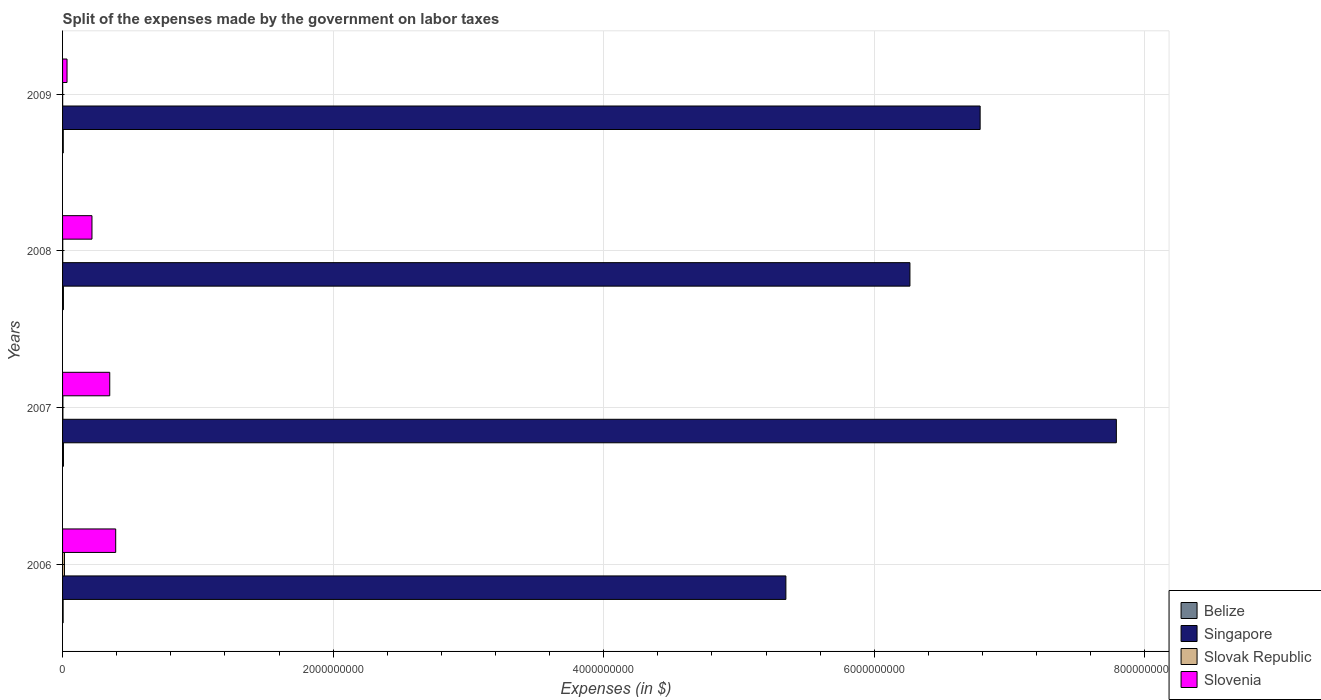How many different coloured bars are there?
Keep it short and to the point. 4. How many groups of bars are there?
Offer a terse response. 4. How many bars are there on the 4th tick from the top?
Ensure brevity in your answer.  4. How many bars are there on the 4th tick from the bottom?
Your response must be concise. 4. What is the label of the 2nd group of bars from the top?
Ensure brevity in your answer.  2008. What is the expenses made by the government on labor taxes in Belize in 2008?
Your answer should be very brief. 6.32e+06. Across all years, what is the maximum expenses made by the government on labor taxes in Slovak Republic?
Your response must be concise. 1.41e+07. Across all years, what is the minimum expenses made by the government on labor taxes in Belize?
Keep it short and to the point. 4.30e+06. In which year was the expenses made by the government on labor taxes in Slovenia maximum?
Make the answer very short. 2006. In which year was the expenses made by the government on labor taxes in Slovak Republic minimum?
Your answer should be compact. 2009. What is the total expenses made by the government on labor taxes in Singapore in the graph?
Ensure brevity in your answer.  2.62e+1. What is the difference between the expenses made by the government on labor taxes in Slovak Republic in 2006 and that in 2008?
Make the answer very short. 1.27e+07. What is the difference between the expenses made by the government on labor taxes in Singapore in 2006 and the expenses made by the government on labor taxes in Slovenia in 2007?
Give a very brief answer. 5.00e+09. What is the average expenses made by the government on labor taxes in Singapore per year?
Offer a very short reply. 6.55e+09. In the year 2006, what is the difference between the expenses made by the government on labor taxes in Slovenia and expenses made by the government on labor taxes in Singapore?
Your answer should be very brief. -4.95e+09. What is the ratio of the expenses made by the government on labor taxes in Singapore in 2007 to that in 2008?
Your answer should be compact. 1.24. What is the difference between the highest and the second highest expenses made by the government on labor taxes in Belize?
Give a very brief answer. 1.98e+05. What is the difference between the highest and the lowest expenses made by the government on labor taxes in Belize?
Ensure brevity in your answer.  2.22e+06. In how many years, is the expenses made by the government on labor taxes in Singapore greater than the average expenses made by the government on labor taxes in Singapore taken over all years?
Keep it short and to the point. 2. What does the 2nd bar from the top in 2009 represents?
Offer a terse response. Slovak Republic. What does the 3rd bar from the bottom in 2006 represents?
Your answer should be very brief. Slovak Republic. Is it the case that in every year, the sum of the expenses made by the government on labor taxes in Belize and expenses made by the government on labor taxes in Slovenia is greater than the expenses made by the government on labor taxes in Slovak Republic?
Provide a short and direct response. Yes. Are the values on the major ticks of X-axis written in scientific E-notation?
Offer a terse response. No. Does the graph contain any zero values?
Ensure brevity in your answer.  No. Where does the legend appear in the graph?
Keep it short and to the point. Bottom right. How are the legend labels stacked?
Offer a terse response. Vertical. What is the title of the graph?
Your answer should be compact. Split of the expenses made by the government on labor taxes. What is the label or title of the X-axis?
Your response must be concise. Expenses (in $). What is the Expenses (in $) in Belize in 2006?
Give a very brief answer. 4.30e+06. What is the Expenses (in $) of Singapore in 2006?
Offer a terse response. 5.35e+09. What is the Expenses (in $) in Slovak Republic in 2006?
Provide a short and direct response. 1.41e+07. What is the Expenses (in $) in Slovenia in 2006?
Give a very brief answer. 3.93e+08. What is the Expenses (in $) in Belize in 2007?
Provide a succinct answer. 6.52e+06. What is the Expenses (in $) in Singapore in 2007?
Ensure brevity in your answer.  7.79e+09. What is the Expenses (in $) of Slovak Republic in 2007?
Provide a short and direct response. 2.58e+06. What is the Expenses (in $) of Slovenia in 2007?
Offer a very short reply. 3.49e+08. What is the Expenses (in $) of Belize in 2008?
Provide a short and direct response. 6.32e+06. What is the Expenses (in $) of Singapore in 2008?
Your answer should be very brief. 6.26e+09. What is the Expenses (in $) of Slovak Republic in 2008?
Provide a succinct answer. 1.39e+06. What is the Expenses (in $) of Slovenia in 2008?
Offer a terse response. 2.17e+08. What is the Expenses (in $) of Belize in 2009?
Give a very brief answer. 5.26e+06. What is the Expenses (in $) of Singapore in 2009?
Offer a terse response. 6.78e+09. What is the Expenses (in $) of Slovak Republic in 2009?
Offer a terse response. 7.25e+05. What is the Expenses (in $) of Slovenia in 2009?
Provide a succinct answer. 3.31e+07. Across all years, what is the maximum Expenses (in $) in Belize?
Your answer should be compact. 6.52e+06. Across all years, what is the maximum Expenses (in $) in Singapore?
Ensure brevity in your answer.  7.79e+09. Across all years, what is the maximum Expenses (in $) in Slovak Republic?
Ensure brevity in your answer.  1.41e+07. Across all years, what is the maximum Expenses (in $) of Slovenia?
Make the answer very short. 3.93e+08. Across all years, what is the minimum Expenses (in $) in Belize?
Offer a very short reply. 4.30e+06. Across all years, what is the minimum Expenses (in $) of Singapore?
Your response must be concise. 5.35e+09. Across all years, what is the minimum Expenses (in $) in Slovak Republic?
Your answer should be very brief. 7.25e+05. Across all years, what is the minimum Expenses (in $) of Slovenia?
Give a very brief answer. 3.31e+07. What is the total Expenses (in $) in Belize in the graph?
Provide a succinct answer. 2.24e+07. What is the total Expenses (in $) in Singapore in the graph?
Offer a very short reply. 2.62e+1. What is the total Expenses (in $) in Slovak Republic in the graph?
Your response must be concise. 1.88e+07. What is the total Expenses (in $) in Slovenia in the graph?
Offer a terse response. 9.92e+08. What is the difference between the Expenses (in $) in Belize in 2006 and that in 2007?
Provide a succinct answer. -2.22e+06. What is the difference between the Expenses (in $) in Singapore in 2006 and that in 2007?
Offer a very short reply. -2.44e+09. What is the difference between the Expenses (in $) in Slovak Republic in 2006 and that in 2007?
Make the answer very short. 1.15e+07. What is the difference between the Expenses (in $) of Slovenia in 2006 and that in 2007?
Give a very brief answer. 4.41e+07. What is the difference between the Expenses (in $) of Belize in 2006 and that in 2008?
Your answer should be very brief. -2.03e+06. What is the difference between the Expenses (in $) of Singapore in 2006 and that in 2008?
Offer a terse response. -9.17e+08. What is the difference between the Expenses (in $) of Slovak Republic in 2006 and that in 2008?
Provide a succinct answer. 1.27e+07. What is the difference between the Expenses (in $) of Slovenia in 2006 and that in 2008?
Provide a short and direct response. 1.75e+08. What is the difference between the Expenses (in $) in Belize in 2006 and that in 2009?
Keep it short and to the point. -9.65e+05. What is the difference between the Expenses (in $) in Singapore in 2006 and that in 2009?
Your answer should be compact. -1.44e+09. What is the difference between the Expenses (in $) in Slovak Republic in 2006 and that in 2009?
Provide a short and direct response. 1.34e+07. What is the difference between the Expenses (in $) of Slovenia in 2006 and that in 2009?
Offer a terse response. 3.60e+08. What is the difference between the Expenses (in $) of Belize in 2007 and that in 2008?
Ensure brevity in your answer.  1.98e+05. What is the difference between the Expenses (in $) in Singapore in 2007 and that in 2008?
Keep it short and to the point. 1.53e+09. What is the difference between the Expenses (in $) of Slovak Republic in 2007 and that in 2008?
Provide a short and direct response. 1.19e+06. What is the difference between the Expenses (in $) in Slovenia in 2007 and that in 2008?
Offer a terse response. 1.31e+08. What is the difference between the Expenses (in $) of Belize in 2007 and that in 2009?
Your answer should be very brief. 1.26e+06. What is the difference between the Expenses (in $) in Singapore in 2007 and that in 2009?
Ensure brevity in your answer.  1.01e+09. What is the difference between the Expenses (in $) in Slovak Republic in 2007 and that in 2009?
Your answer should be compact. 1.86e+06. What is the difference between the Expenses (in $) of Slovenia in 2007 and that in 2009?
Give a very brief answer. 3.16e+08. What is the difference between the Expenses (in $) of Belize in 2008 and that in 2009?
Your response must be concise. 1.06e+06. What is the difference between the Expenses (in $) in Singapore in 2008 and that in 2009?
Offer a very short reply. -5.19e+08. What is the difference between the Expenses (in $) in Slovak Republic in 2008 and that in 2009?
Provide a succinct answer. 6.67e+05. What is the difference between the Expenses (in $) of Slovenia in 2008 and that in 2009?
Keep it short and to the point. 1.84e+08. What is the difference between the Expenses (in $) of Belize in 2006 and the Expenses (in $) of Singapore in 2007?
Provide a short and direct response. -7.79e+09. What is the difference between the Expenses (in $) of Belize in 2006 and the Expenses (in $) of Slovak Republic in 2007?
Offer a very short reply. 1.71e+06. What is the difference between the Expenses (in $) of Belize in 2006 and the Expenses (in $) of Slovenia in 2007?
Ensure brevity in your answer.  -3.44e+08. What is the difference between the Expenses (in $) in Singapore in 2006 and the Expenses (in $) in Slovak Republic in 2007?
Offer a terse response. 5.34e+09. What is the difference between the Expenses (in $) in Singapore in 2006 and the Expenses (in $) in Slovenia in 2007?
Keep it short and to the point. 5.00e+09. What is the difference between the Expenses (in $) in Slovak Republic in 2006 and the Expenses (in $) in Slovenia in 2007?
Offer a terse response. -3.35e+08. What is the difference between the Expenses (in $) in Belize in 2006 and the Expenses (in $) in Singapore in 2008?
Your answer should be compact. -6.26e+09. What is the difference between the Expenses (in $) in Belize in 2006 and the Expenses (in $) in Slovak Republic in 2008?
Your answer should be compact. 2.91e+06. What is the difference between the Expenses (in $) of Belize in 2006 and the Expenses (in $) of Slovenia in 2008?
Offer a very short reply. -2.13e+08. What is the difference between the Expenses (in $) of Singapore in 2006 and the Expenses (in $) of Slovak Republic in 2008?
Your response must be concise. 5.35e+09. What is the difference between the Expenses (in $) in Singapore in 2006 and the Expenses (in $) in Slovenia in 2008?
Ensure brevity in your answer.  5.13e+09. What is the difference between the Expenses (in $) of Slovak Republic in 2006 and the Expenses (in $) of Slovenia in 2008?
Offer a terse response. -2.03e+08. What is the difference between the Expenses (in $) of Belize in 2006 and the Expenses (in $) of Singapore in 2009?
Provide a succinct answer. -6.78e+09. What is the difference between the Expenses (in $) of Belize in 2006 and the Expenses (in $) of Slovak Republic in 2009?
Your answer should be compact. 3.57e+06. What is the difference between the Expenses (in $) of Belize in 2006 and the Expenses (in $) of Slovenia in 2009?
Your answer should be compact. -2.88e+07. What is the difference between the Expenses (in $) of Singapore in 2006 and the Expenses (in $) of Slovak Republic in 2009?
Give a very brief answer. 5.35e+09. What is the difference between the Expenses (in $) of Singapore in 2006 and the Expenses (in $) of Slovenia in 2009?
Keep it short and to the point. 5.31e+09. What is the difference between the Expenses (in $) of Slovak Republic in 2006 and the Expenses (in $) of Slovenia in 2009?
Your answer should be compact. -1.89e+07. What is the difference between the Expenses (in $) of Belize in 2007 and the Expenses (in $) of Singapore in 2008?
Offer a very short reply. -6.26e+09. What is the difference between the Expenses (in $) of Belize in 2007 and the Expenses (in $) of Slovak Republic in 2008?
Offer a very short reply. 5.13e+06. What is the difference between the Expenses (in $) in Belize in 2007 and the Expenses (in $) in Slovenia in 2008?
Keep it short and to the point. -2.11e+08. What is the difference between the Expenses (in $) in Singapore in 2007 and the Expenses (in $) in Slovak Republic in 2008?
Make the answer very short. 7.79e+09. What is the difference between the Expenses (in $) of Singapore in 2007 and the Expenses (in $) of Slovenia in 2008?
Make the answer very short. 7.57e+09. What is the difference between the Expenses (in $) of Slovak Republic in 2007 and the Expenses (in $) of Slovenia in 2008?
Your answer should be very brief. -2.15e+08. What is the difference between the Expenses (in $) in Belize in 2007 and the Expenses (in $) in Singapore in 2009?
Ensure brevity in your answer.  -6.78e+09. What is the difference between the Expenses (in $) of Belize in 2007 and the Expenses (in $) of Slovak Republic in 2009?
Offer a terse response. 5.80e+06. What is the difference between the Expenses (in $) in Belize in 2007 and the Expenses (in $) in Slovenia in 2009?
Give a very brief answer. -2.65e+07. What is the difference between the Expenses (in $) of Singapore in 2007 and the Expenses (in $) of Slovak Republic in 2009?
Give a very brief answer. 7.79e+09. What is the difference between the Expenses (in $) of Singapore in 2007 and the Expenses (in $) of Slovenia in 2009?
Keep it short and to the point. 7.76e+09. What is the difference between the Expenses (in $) of Slovak Republic in 2007 and the Expenses (in $) of Slovenia in 2009?
Ensure brevity in your answer.  -3.05e+07. What is the difference between the Expenses (in $) of Belize in 2008 and the Expenses (in $) of Singapore in 2009?
Your answer should be compact. -6.78e+09. What is the difference between the Expenses (in $) of Belize in 2008 and the Expenses (in $) of Slovak Republic in 2009?
Provide a succinct answer. 5.60e+06. What is the difference between the Expenses (in $) of Belize in 2008 and the Expenses (in $) of Slovenia in 2009?
Keep it short and to the point. -2.67e+07. What is the difference between the Expenses (in $) of Singapore in 2008 and the Expenses (in $) of Slovak Republic in 2009?
Offer a very short reply. 6.26e+09. What is the difference between the Expenses (in $) in Singapore in 2008 and the Expenses (in $) in Slovenia in 2009?
Keep it short and to the point. 6.23e+09. What is the difference between the Expenses (in $) of Slovak Republic in 2008 and the Expenses (in $) of Slovenia in 2009?
Ensure brevity in your answer.  -3.17e+07. What is the average Expenses (in $) of Belize per year?
Your answer should be compact. 5.60e+06. What is the average Expenses (in $) in Singapore per year?
Your answer should be compact. 6.55e+09. What is the average Expenses (in $) of Slovak Republic per year?
Your response must be concise. 4.70e+06. What is the average Expenses (in $) of Slovenia per year?
Keep it short and to the point. 2.48e+08. In the year 2006, what is the difference between the Expenses (in $) of Belize and Expenses (in $) of Singapore?
Offer a terse response. -5.34e+09. In the year 2006, what is the difference between the Expenses (in $) in Belize and Expenses (in $) in Slovak Republic?
Make the answer very short. -9.81e+06. In the year 2006, what is the difference between the Expenses (in $) in Belize and Expenses (in $) in Slovenia?
Offer a terse response. -3.89e+08. In the year 2006, what is the difference between the Expenses (in $) of Singapore and Expenses (in $) of Slovak Republic?
Keep it short and to the point. 5.33e+09. In the year 2006, what is the difference between the Expenses (in $) of Singapore and Expenses (in $) of Slovenia?
Give a very brief answer. 4.95e+09. In the year 2006, what is the difference between the Expenses (in $) of Slovak Republic and Expenses (in $) of Slovenia?
Keep it short and to the point. -3.79e+08. In the year 2007, what is the difference between the Expenses (in $) in Belize and Expenses (in $) in Singapore?
Ensure brevity in your answer.  -7.78e+09. In the year 2007, what is the difference between the Expenses (in $) of Belize and Expenses (in $) of Slovak Republic?
Your answer should be compact. 3.94e+06. In the year 2007, what is the difference between the Expenses (in $) of Belize and Expenses (in $) of Slovenia?
Provide a succinct answer. -3.42e+08. In the year 2007, what is the difference between the Expenses (in $) in Singapore and Expenses (in $) in Slovak Republic?
Provide a short and direct response. 7.79e+09. In the year 2007, what is the difference between the Expenses (in $) in Singapore and Expenses (in $) in Slovenia?
Ensure brevity in your answer.  7.44e+09. In the year 2007, what is the difference between the Expenses (in $) in Slovak Republic and Expenses (in $) in Slovenia?
Make the answer very short. -3.46e+08. In the year 2008, what is the difference between the Expenses (in $) in Belize and Expenses (in $) in Singapore?
Give a very brief answer. -6.26e+09. In the year 2008, what is the difference between the Expenses (in $) of Belize and Expenses (in $) of Slovak Republic?
Offer a terse response. 4.93e+06. In the year 2008, what is the difference between the Expenses (in $) in Belize and Expenses (in $) in Slovenia?
Your answer should be compact. -2.11e+08. In the year 2008, what is the difference between the Expenses (in $) of Singapore and Expenses (in $) of Slovak Republic?
Provide a succinct answer. 6.26e+09. In the year 2008, what is the difference between the Expenses (in $) in Singapore and Expenses (in $) in Slovenia?
Provide a succinct answer. 6.05e+09. In the year 2008, what is the difference between the Expenses (in $) in Slovak Republic and Expenses (in $) in Slovenia?
Ensure brevity in your answer.  -2.16e+08. In the year 2009, what is the difference between the Expenses (in $) of Belize and Expenses (in $) of Singapore?
Provide a short and direct response. -6.78e+09. In the year 2009, what is the difference between the Expenses (in $) in Belize and Expenses (in $) in Slovak Republic?
Offer a very short reply. 4.54e+06. In the year 2009, what is the difference between the Expenses (in $) in Belize and Expenses (in $) in Slovenia?
Your answer should be very brief. -2.78e+07. In the year 2009, what is the difference between the Expenses (in $) in Singapore and Expenses (in $) in Slovak Republic?
Give a very brief answer. 6.78e+09. In the year 2009, what is the difference between the Expenses (in $) of Singapore and Expenses (in $) of Slovenia?
Ensure brevity in your answer.  6.75e+09. In the year 2009, what is the difference between the Expenses (in $) in Slovak Republic and Expenses (in $) in Slovenia?
Give a very brief answer. -3.23e+07. What is the ratio of the Expenses (in $) of Belize in 2006 to that in 2007?
Make the answer very short. 0.66. What is the ratio of the Expenses (in $) in Singapore in 2006 to that in 2007?
Your response must be concise. 0.69. What is the ratio of the Expenses (in $) in Slovak Republic in 2006 to that in 2007?
Provide a succinct answer. 5.46. What is the ratio of the Expenses (in $) of Slovenia in 2006 to that in 2007?
Keep it short and to the point. 1.13. What is the ratio of the Expenses (in $) in Belize in 2006 to that in 2008?
Give a very brief answer. 0.68. What is the ratio of the Expenses (in $) of Singapore in 2006 to that in 2008?
Give a very brief answer. 0.85. What is the ratio of the Expenses (in $) in Slovak Republic in 2006 to that in 2008?
Provide a short and direct response. 10.14. What is the ratio of the Expenses (in $) in Slovenia in 2006 to that in 2008?
Provide a short and direct response. 1.81. What is the ratio of the Expenses (in $) in Belize in 2006 to that in 2009?
Your answer should be compact. 0.82. What is the ratio of the Expenses (in $) of Singapore in 2006 to that in 2009?
Provide a succinct answer. 0.79. What is the ratio of the Expenses (in $) of Slovak Republic in 2006 to that in 2009?
Your answer should be very brief. 19.46. What is the ratio of the Expenses (in $) of Slovenia in 2006 to that in 2009?
Make the answer very short. 11.88. What is the ratio of the Expenses (in $) in Belize in 2007 to that in 2008?
Keep it short and to the point. 1.03. What is the ratio of the Expenses (in $) in Singapore in 2007 to that in 2008?
Offer a terse response. 1.24. What is the ratio of the Expenses (in $) of Slovak Republic in 2007 to that in 2008?
Make the answer very short. 1.86. What is the ratio of the Expenses (in $) of Slovenia in 2007 to that in 2008?
Offer a terse response. 1.6. What is the ratio of the Expenses (in $) of Belize in 2007 to that in 2009?
Ensure brevity in your answer.  1.24. What is the ratio of the Expenses (in $) in Singapore in 2007 to that in 2009?
Ensure brevity in your answer.  1.15. What is the ratio of the Expenses (in $) of Slovak Republic in 2007 to that in 2009?
Make the answer very short. 3.56. What is the ratio of the Expenses (in $) in Slovenia in 2007 to that in 2009?
Your answer should be compact. 10.55. What is the ratio of the Expenses (in $) in Belize in 2008 to that in 2009?
Offer a very short reply. 1.2. What is the ratio of the Expenses (in $) in Singapore in 2008 to that in 2009?
Ensure brevity in your answer.  0.92. What is the ratio of the Expenses (in $) in Slovak Republic in 2008 to that in 2009?
Your answer should be compact. 1.92. What is the ratio of the Expenses (in $) in Slovenia in 2008 to that in 2009?
Provide a short and direct response. 6.58. What is the difference between the highest and the second highest Expenses (in $) in Belize?
Your answer should be very brief. 1.98e+05. What is the difference between the highest and the second highest Expenses (in $) in Singapore?
Your answer should be very brief. 1.01e+09. What is the difference between the highest and the second highest Expenses (in $) of Slovak Republic?
Give a very brief answer. 1.15e+07. What is the difference between the highest and the second highest Expenses (in $) of Slovenia?
Your answer should be compact. 4.41e+07. What is the difference between the highest and the lowest Expenses (in $) in Belize?
Your answer should be compact. 2.22e+06. What is the difference between the highest and the lowest Expenses (in $) of Singapore?
Offer a terse response. 2.44e+09. What is the difference between the highest and the lowest Expenses (in $) in Slovak Republic?
Your answer should be very brief. 1.34e+07. What is the difference between the highest and the lowest Expenses (in $) of Slovenia?
Provide a succinct answer. 3.60e+08. 